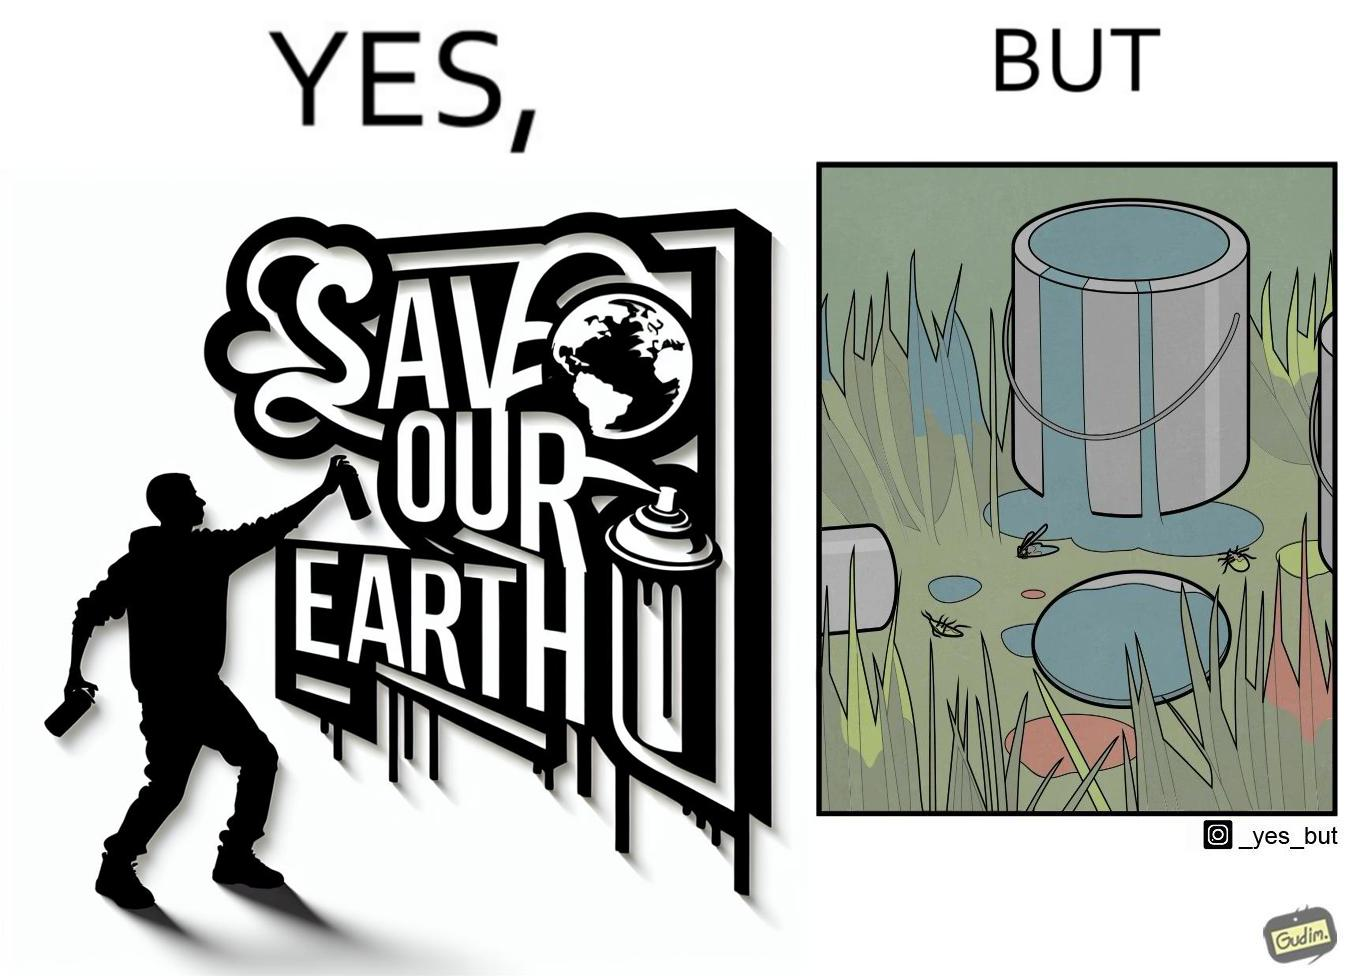What do you see in each half of this image? In the left part of the image: A man drawing a graffiti themed "save Our earth". In the right part of the image: A can of paint, overflowing onto the grass. The paint seems to be harmful for insects. 